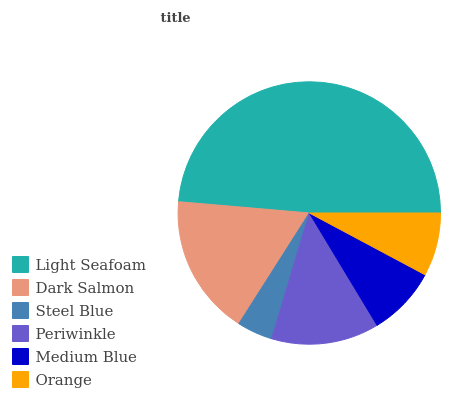Is Steel Blue the minimum?
Answer yes or no. Yes. Is Light Seafoam the maximum?
Answer yes or no. Yes. Is Dark Salmon the minimum?
Answer yes or no. No. Is Dark Salmon the maximum?
Answer yes or no. No. Is Light Seafoam greater than Dark Salmon?
Answer yes or no. Yes. Is Dark Salmon less than Light Seafoam?
Answer yes or no. Yes. Is Dark Salmon greater than Light Seafoam?
Answer yes or no. No. Is Light Seafoam less than Dark Salmon?
Answer yes or no. No. Is Periwinkle the high median?
Answer yes or no. Yes. Is Medium Blue the low median?
Answer yes or no. Yes. Is Light Seafoam the high median?
Answer yes or no. No. Is Dark Salmon the low median?
Answer yes or no. No. 